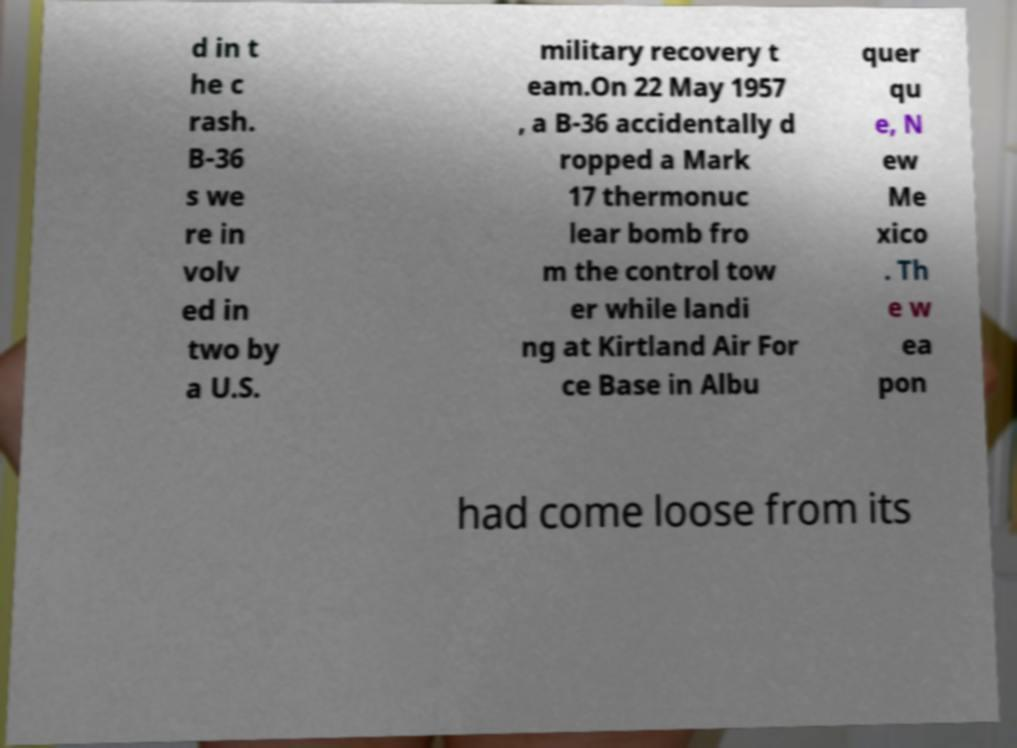For documentation purposes, I need the text within this image transcribed. Could you provide that? d in t he c rash. B-36 s we re in volv ed in two by a U.S. military recovery t eam.On 22 May 1957 , a B-36 accidentally d ropped a Mark 17 thermonuc lear bomb fro m the control tow er while landi ng at Kirtland Air For ce Base in Albu quer qu e, N ew Me xico . Th e w ea pon had come loose from its 